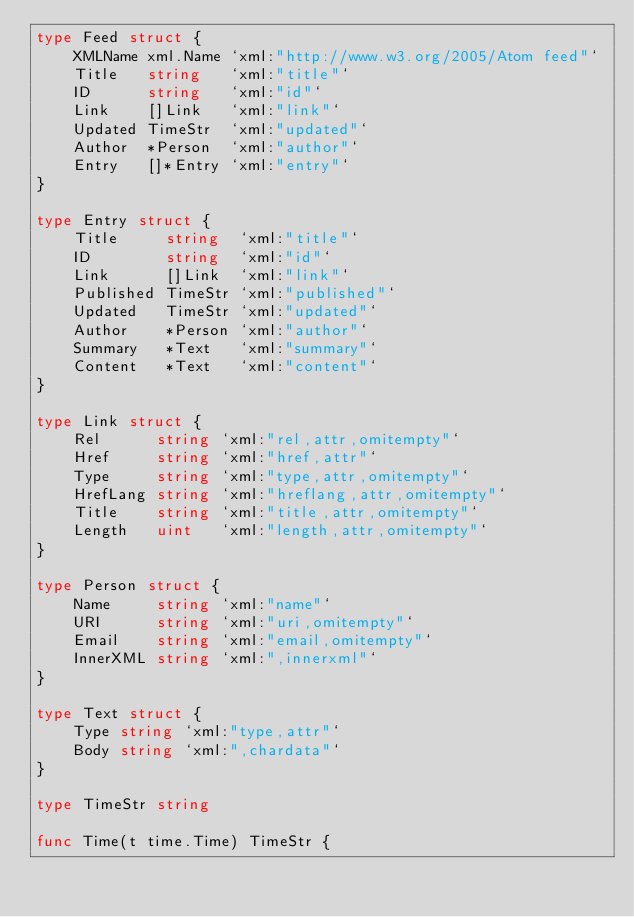Convert code to text. <code><loc_0><loc_0><loc_500><loc_500><_Go_>type Feed struct {
	XMLName xml.Name `xml:"http://www.w3.org/2005/Atom feed"`
	Title   string   `xml:"title"`
	ID      string   `xml:"id"`
	Link    []Link   `xml:"link"`
	Updated TimeStr  `xml:"updated"`
	Author  *Person  `xml:"author"`
	Entry   []*Entry `xml:"entry"`
}

type Entry struct {
	Title     string  `xml:"title"`
	ID        string  `xml:"id"`
	Link      []Link  `xml:"link"`
	Published TimeStr `xml:"published"`
	Updated   TimeStr `xml:"updated"`
	Author    *Person `xml:"author"`
	Summary   *Text   `xml:"summary"`
	Content   *Text   `xml:"content"`
}

type Link struct {
	Rel      string `xml:"rel,attr,omitempty"`
	Href     string `xml:"href,attr"`
	Type     string `xml:"type,attr,omitempty"`
	HrefLang string `xml:"hreflang,attr,omitempty"`
	Title    string `xml:"title,attr,omitempty"`
	Length   uint   `xml:"length,attr,omitempty"`
}

type Person struct {
	Name     string `xml:"name"`
	URI      string `xml:"uri,omitempty"`
	Email    string `xml:"email,omitempty"`
	InnerXML string `xml:",innerxml"`
}

type Text struct {
	Type string `xml:"type,attr"`
	Body string `xml:",chardata"`
}

type TimeStr string

func Time(t time.Time) TimeStr {</code> 